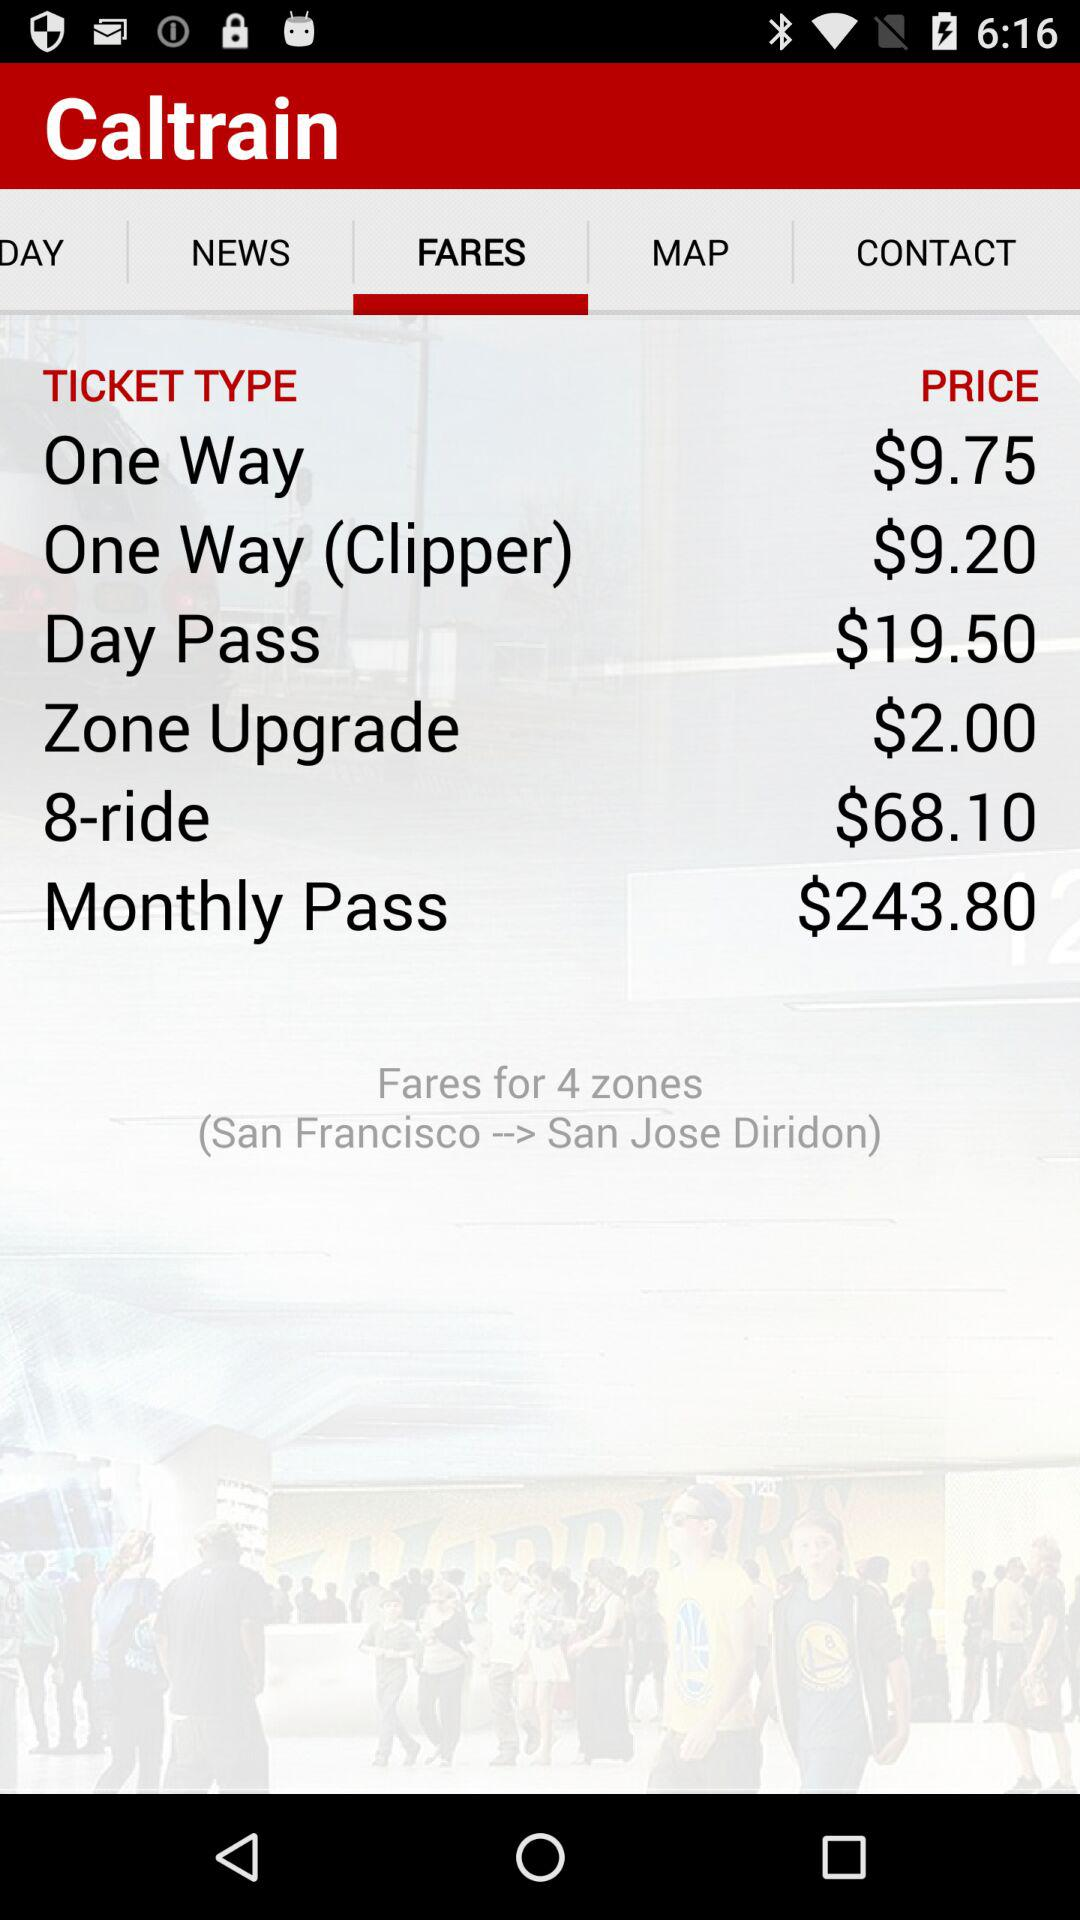Between which stations does the train run? The train runs between "San Francisco" and "San Jose Diridon". 